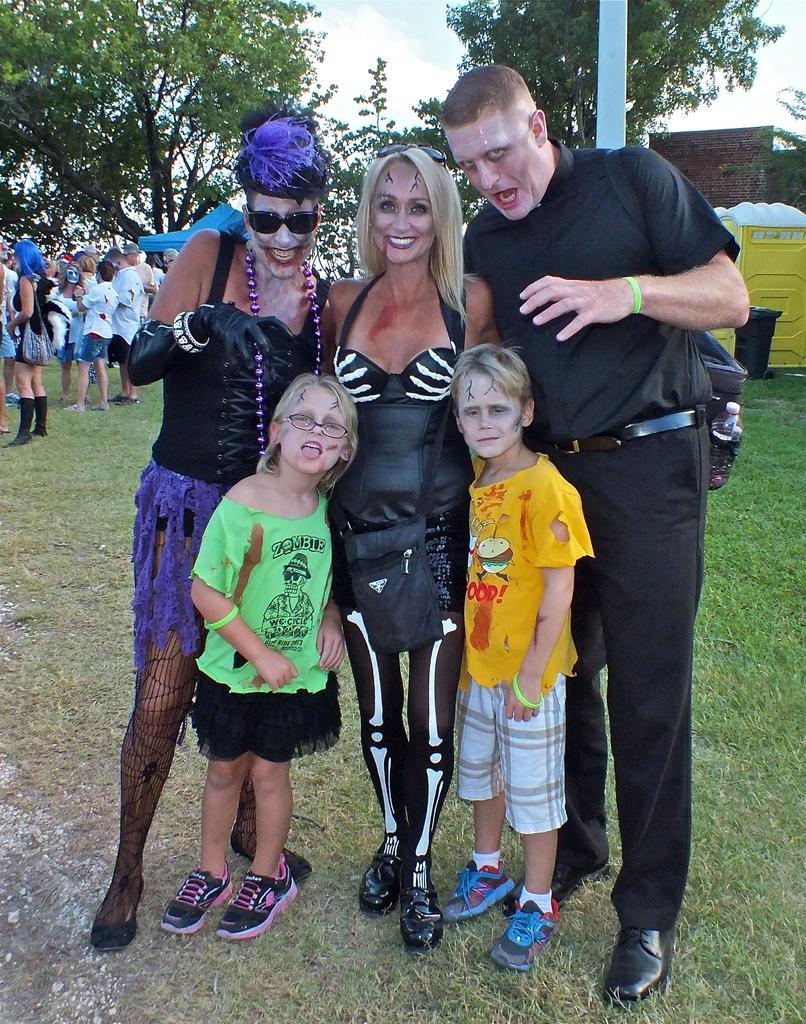Could you give a brief overview of what you see in this image? In this image I can see group of people standing. In front the person is wearing brown and white color dress and the person at left is wearing green and black color dress. Background I can see few persons standing, a tent in blue color, trees in green color and the sky is in white color. 